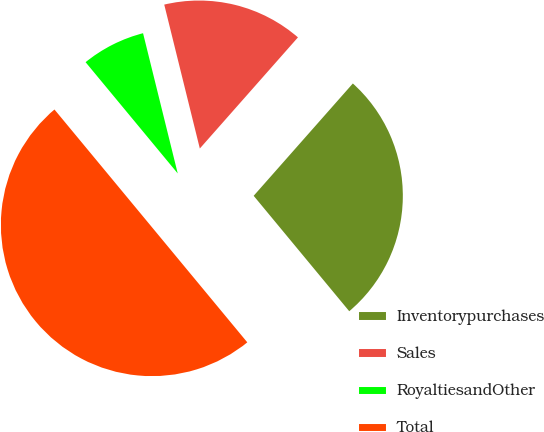Convert chart to OTSL. <chart><loc_0><loc_0><loc_500><loc_500><pie_chart><fcel>Inventorypurchases<fcel>Sales<fcel>RoyaltiesandOther<fcel>Total<nl><fcel>27.48%<fcel>15.37%<fcel>7.15%<fcel>50.0%<nl></chart> 